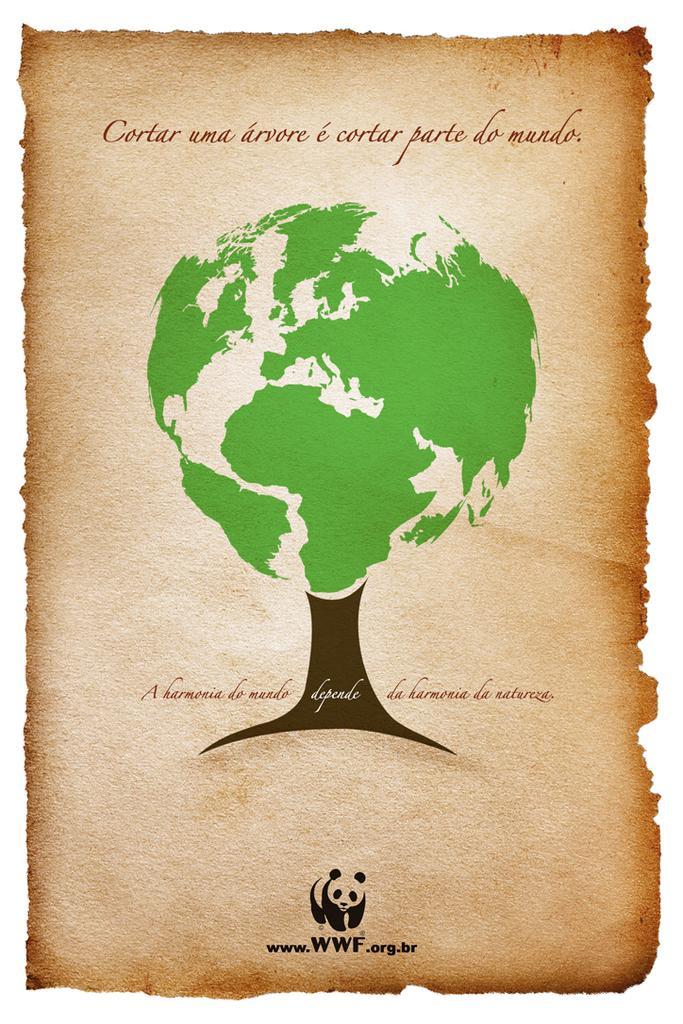Could you give a brief overview of what you see in this image? Picture of a poster. Something written on this poster. Here we can see tree. Bottom of the image there is a logo. 